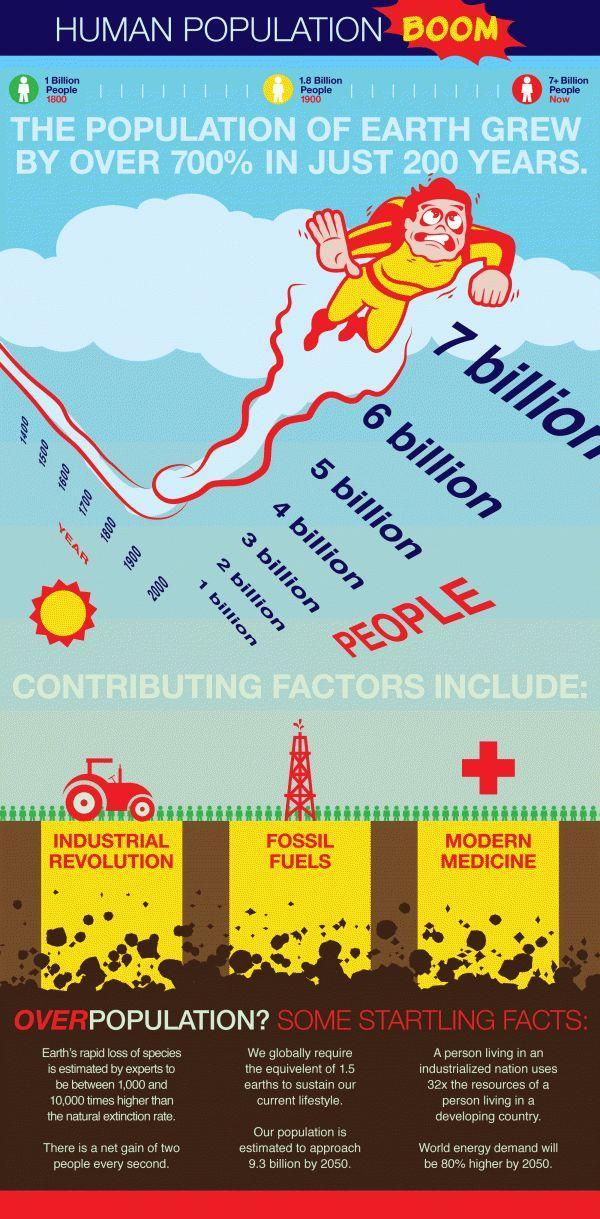Which all factors contribute to the human population?
Answer the question with a short phrase. Industrial Revolution, Fossil Fuels, Modern Medicine How many factors contribute to the human population? 3 